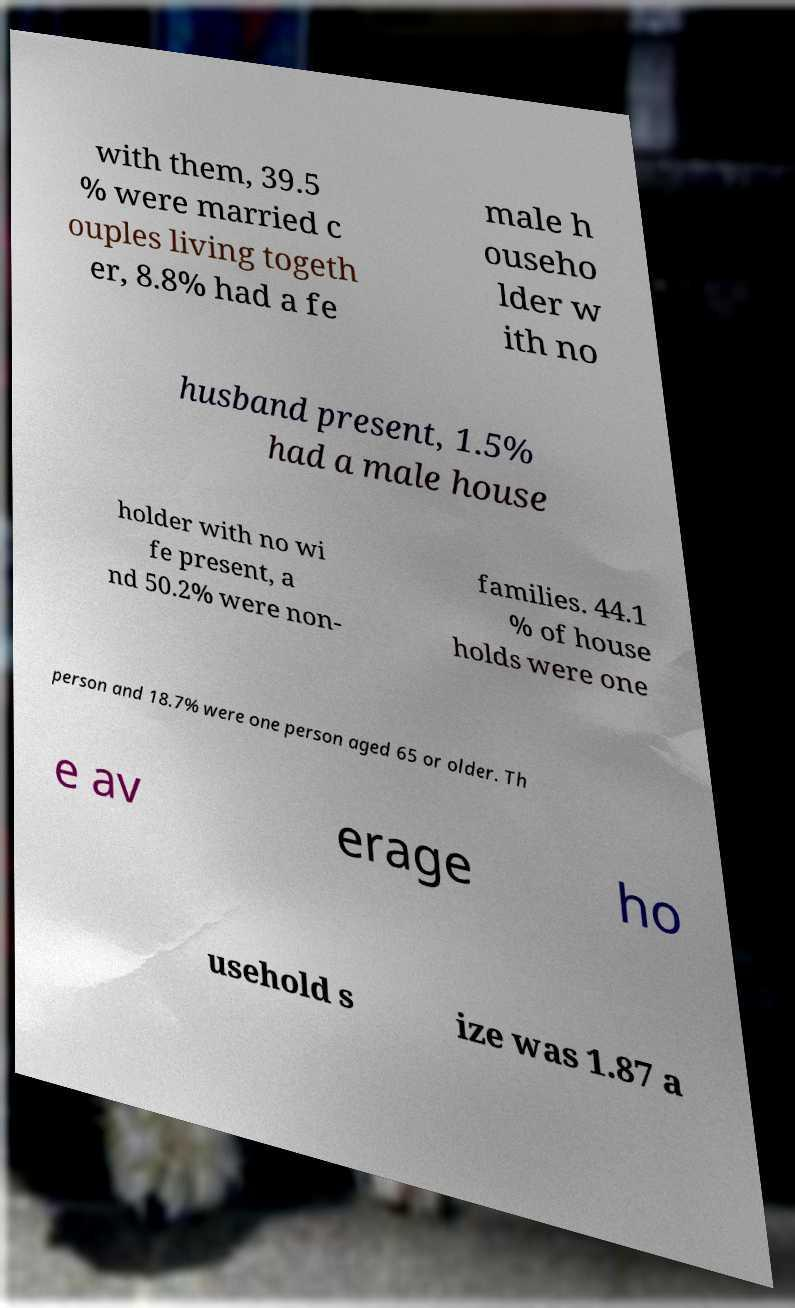Could you extract and type out the text from this image? with them, 39.5 % were married c ouples living togeth er, 8.8% had a fe male h ouseho lder w ith no husband present, 1.5% had a male house holder with no wi fe present, a nd 50.2% were non- families. 44.1 % of house holds were one person and 18.7% were one person aged 65 or older. Th e av erage ho usehold s ize was 1.87 a 